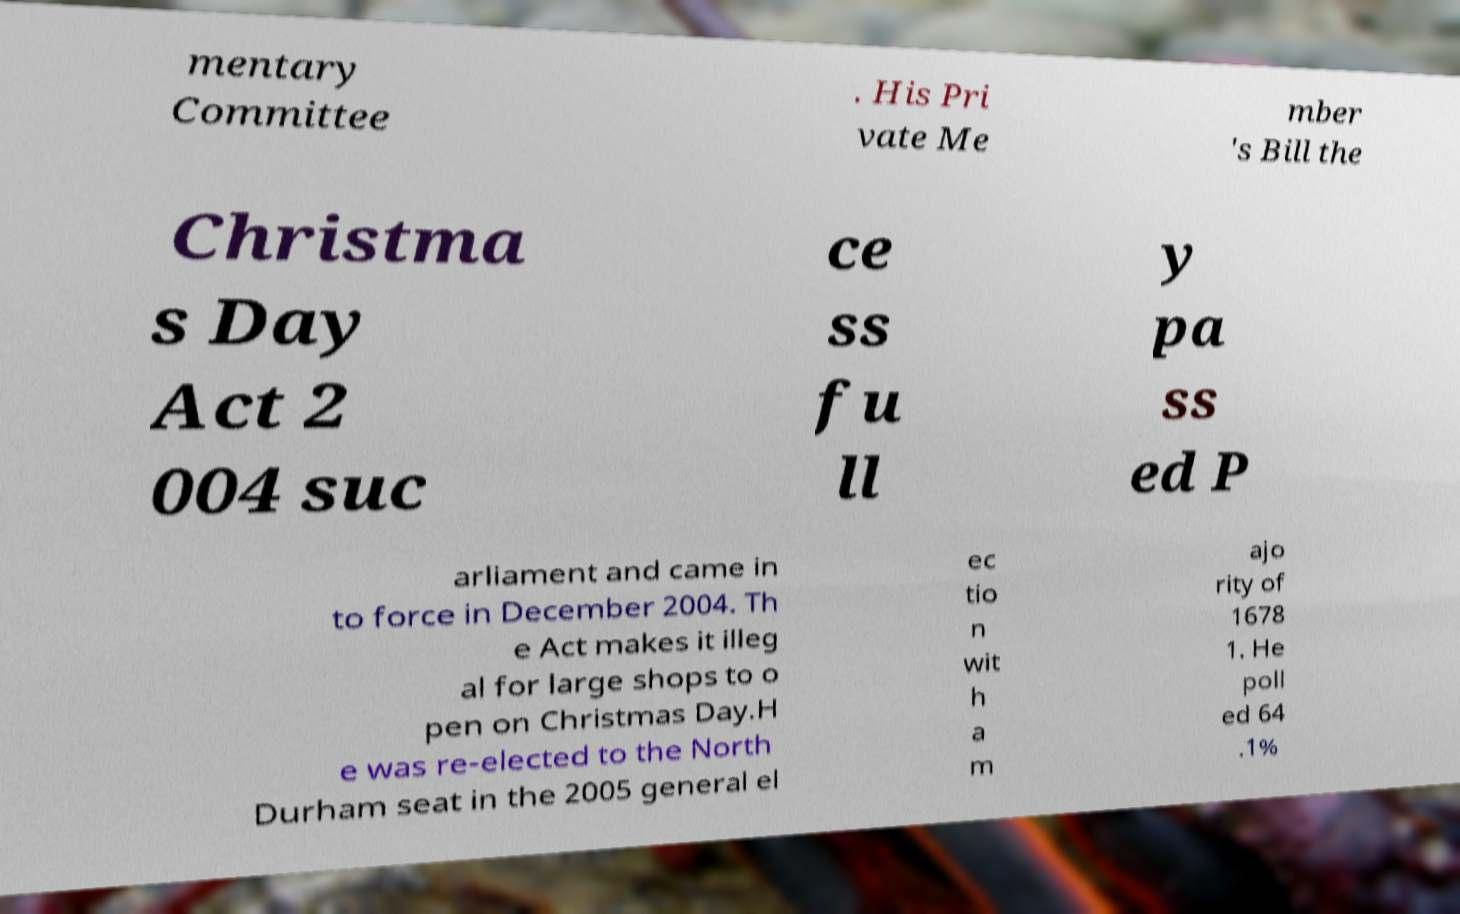There's text embedded in this image that I need extracted. Can you transcribe it verbatim? mentary Committee . His Pri vate Me mber 's Bill the Christma s Day Act 2 004 suc ce ss fu ll y pa ss ed P arliament and came in to force in December 2004. Th e Act makes it illeg al for large shops to o pen on Christmas Day.H e was re-elected to the North Durham seat in the 2005 general el ec tio n wit h a m ajo rity of 1678 1. He poll ed 64 .1% 